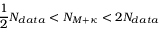<formula> <loc_0><loc_0><loc_500><loc_500>\frac { 1 } { 2 } N _ { d a t a } < N _ { M + \kappa } < 2 N _ { d a t a }</formula> 